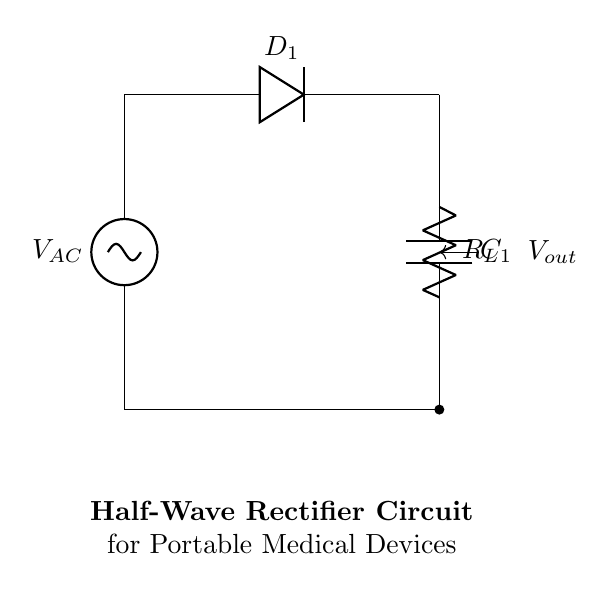What type of rectifier is shown in this circuit? The circuit is a half-wave rectifier, which only allows one half of the AC signal to pass through while blocking the other half. This is indicated by the presence of a single diode.
Answer: Half-wave What component is used to store charge in this circuit? The component used to store charge is a capacitor. In the circuit, it is labeled as C1, which is connected in parallel with the load resistor and helps to smooth out the output voltage.
Answer: Capacitor How many diodes are present in this half-wave rectifier circuit? The circuit has one diode, identified as D1. It only allows current to flow in one direction, which is a key characteristic of half-wave rectifiers.
Answer: One What is the purpose of the load resistor in this circuit? The load resistor, labeled R_L, is used to represent the device or circuit that is being powered by the rectifier. It consumes the output voltage and enables measurement of the circuit's performance under load.
Answer: To consume output voltage What is the output voltage type in this circuit? The output voltage, labeled V_out, is pulsating DC voltage because it is derived from the half-wave rectification of the AC input signal. The diode allows voltage to pass only during one half of the AC waveform, resulting in a pulsed signal.
Answer: Pulsating DC What happens to the negative half of the input AC signal? The negative half of the AC signal is blocked by the diode D1, which means no current flows during that portion of the waveform and thus does not contribute to the output.
Answer: Blocked How does the capacitor influence the output voltage in this circuit? The capacitor C1 charges during the positive half of the input signal and discharges during the negative half, smoothing out the ripple in the output voltage, leading to a more stable DC output voltage.
Answer: Smooths output voltage 